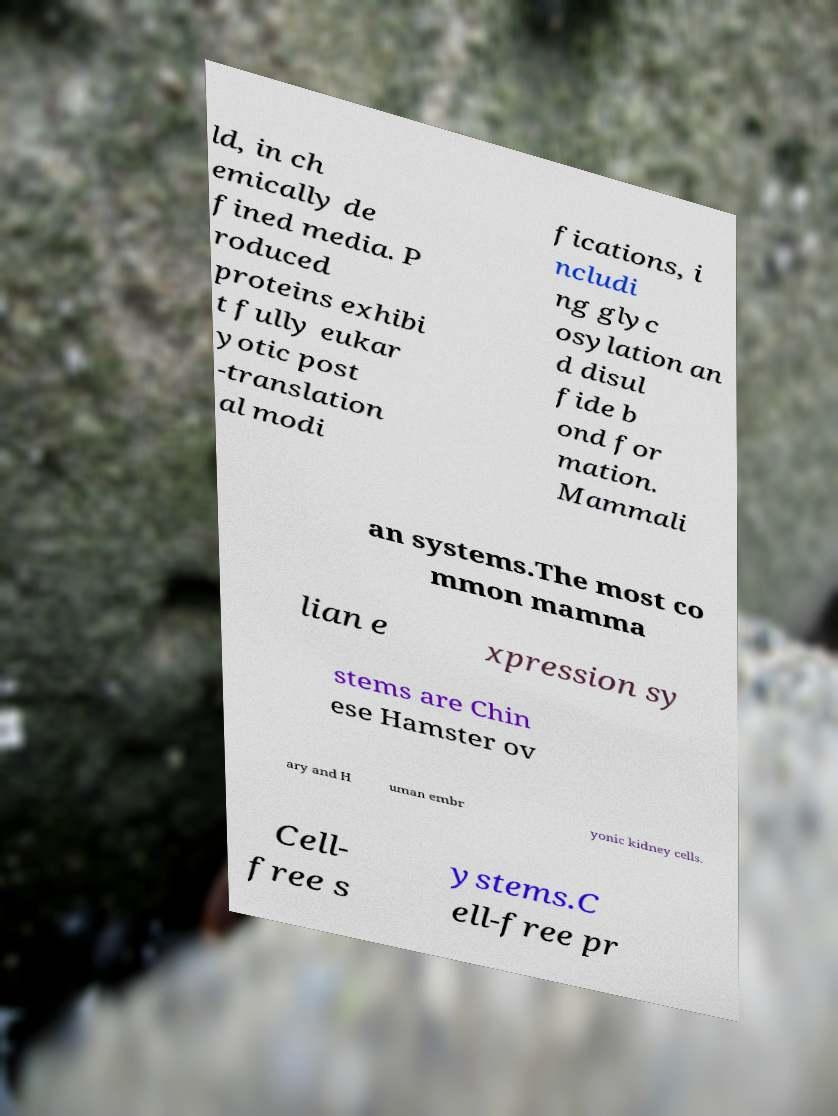Can you accurately transcribe the text from the provided image for me? ld, in ch emically de fined media. P roduced proteins exhibi t fully eukar yotic post -translation al modi fications, i ncludi ng glyc osylation an d disul fide b ond for mation. Mammali an systems.The most co mmon mamma lian e xpression sy stems are Chin ese Hamster ov ary and H uman embr yonic kidney cells. Cell- free s ystems.C ell-free pr 